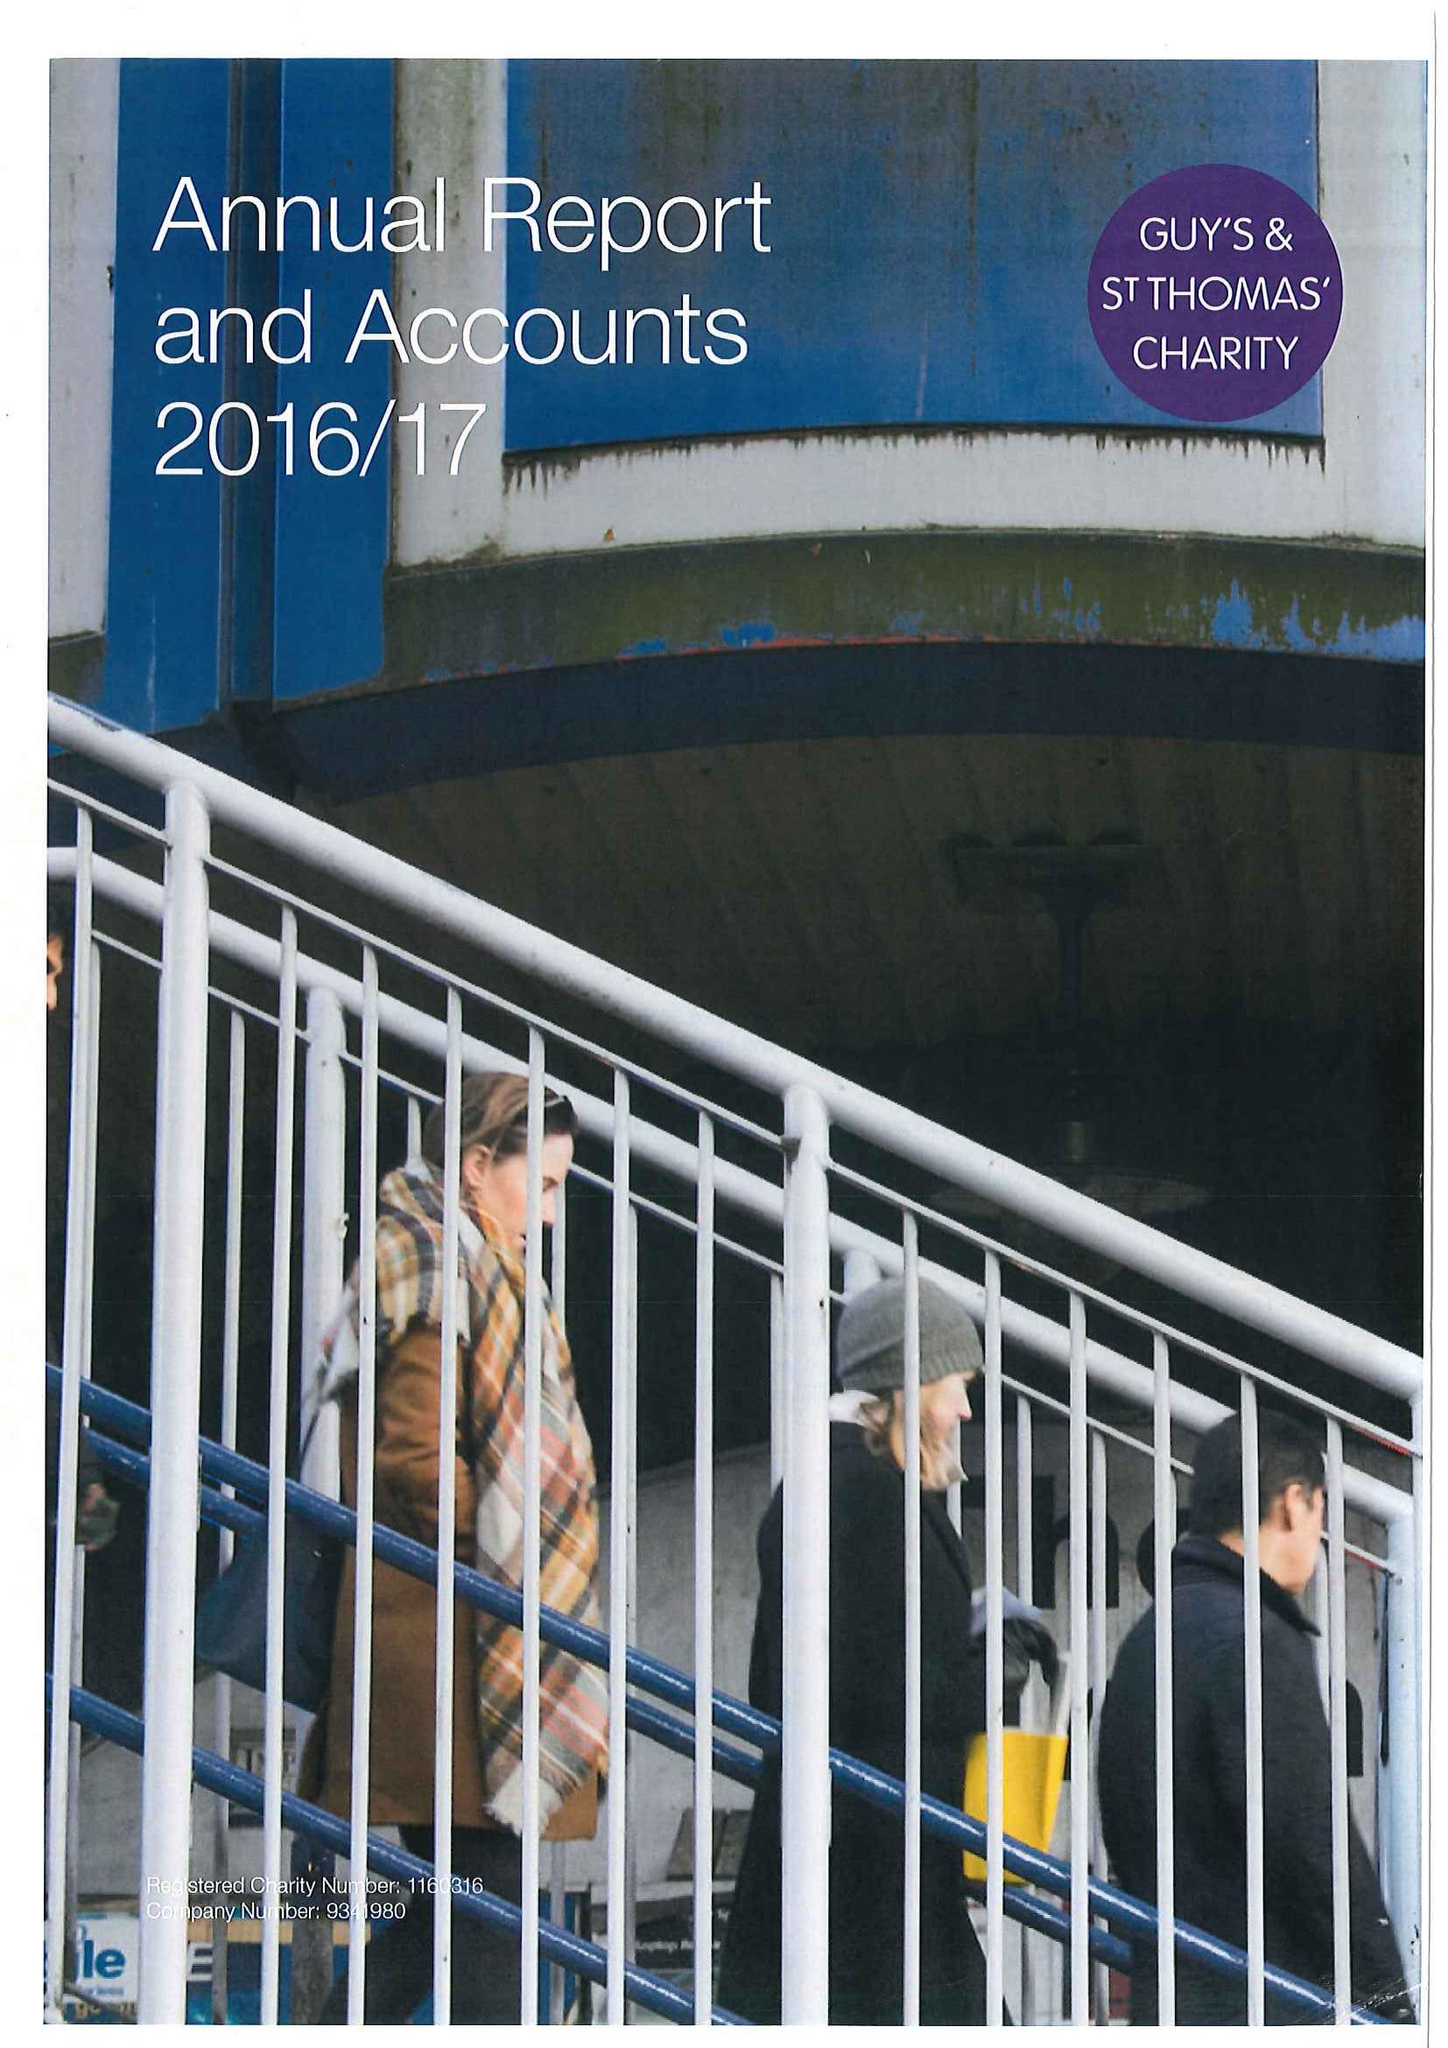What is the value for the charity_name?
Answer the question using a single word or phrase. Guy's and St Thomas' Charity 